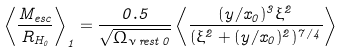Convert formula to latex. <formula><loc_0><loc_0><loc_500><loc_500>\left \langle \frac { M _ { e s c } } { R _ { H _ { 0 } } } \right \rangle _ { 1 } = \frac { 0 . 5 } { \sqrt { \Omega _ { \nu \, r e s t \, 0 } } } \left \langle \frac { ( y / x _ { 0 } ) ^ { 3 } \xi ^ { 2 } } { ( \xi ^ { 2 } + ( y / x _ { 0 } ) ^ { 2 } ) ^ { 7 / 4 } } \right \rangle</formula> 